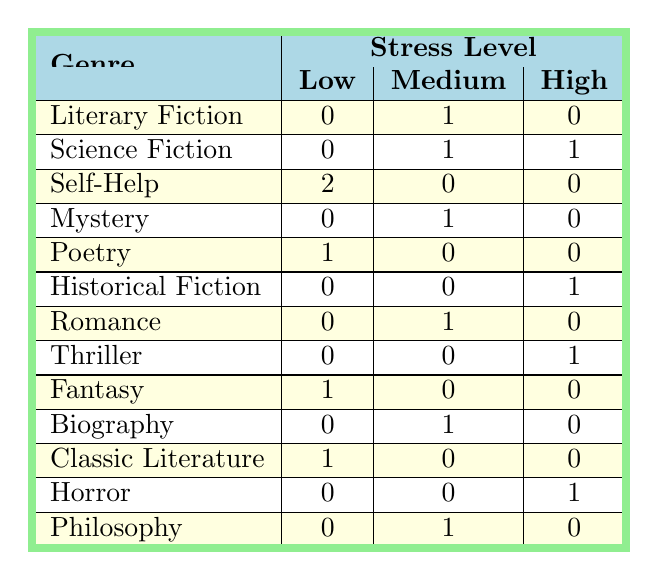What genre has the most participants reporting a high stress level? The genres listed with a high stress level are Science Fiction, Historical Fiction, Thriller, and Horror. Among them, Science Fiction and Thriller each have one participant reporting high stress. Therefore, Science Fiction is the only genre with a high stress level reported by one participant.
Answer: Science Fiction How many genres have two participants reporting low stress levels? The genres with participants reporting low stress levels are Self-Help (2), Poetry (1), Fantasy (1), and Classic Literature (1). Hence, only one genre has two participants reporting low stress levels.
Answer: Self-Help What is the total number of participants who favor genres with medium stress levels? The genres with medium stress levels are Literary Fiction (1), Science Fiction (1), Mystery (1), Romance (1), Biography (1), and Philosophy (1). Summing these gives us 6 participants in total.
Answer: 6 Is there any genre with no participants reporting low stress levels? From the table, we see the genres of Literary Fiction, Science Fiction, Mystery, Historical Fiction, Romance, Thriller, Horror, and Philosophy show no participants reporting low stress levels. Therefore, the answer is yes.
Answer: Yes What is the difference between the number of genres with low stress levels and those with high stress levels? The genres with low stress levels are Self-Help (2), Poetry (1), Fantasy (1), and Classic Literature (1) totaling 5 genres. The genres with high stress levels are Science Fiction (1), Historical Fiction (1), Thriller (1), and Horror (1) totaling 4 genres. Therefore, the difference is 5 - 4 = 1.
Answer: 1 Which stress level is most frequently reported across all genres? After analyzing the table, low stress occurs 5 times, medium stress occurs 7 times, and high stress occurs 4 times. Medium stress is the most frequent reported level.
Answer: Medium How many genres have the same reported stress level of "Medium"? The genres that have a medium stress level are Literary Fiction, Science Fiction, Mystery, Romance, Biography, Philosophy, and Historical Fiction totaling 6 genres.
Answer: 6 Does any participant who prefers Science Fiction report low stress? Reviewing the table, both participants who favor Science Fiction report either medium or high stress but no one reports low stress associated with that genre.
Answer: No What genre has the lowest overall stress levels, summing up across all reported stress levels? The genres are summed as follows: Self-Help (2 + 0 + 0), Poetry (1 + 0 + 0), Fantasy (1 + 0 + 0), and Classic Literature (1 + 0 + 0). Self-Help has the highest low stress level total, with a total of 2, whereas others have lower totals for their low stress counts.
Answer: Self-Help 